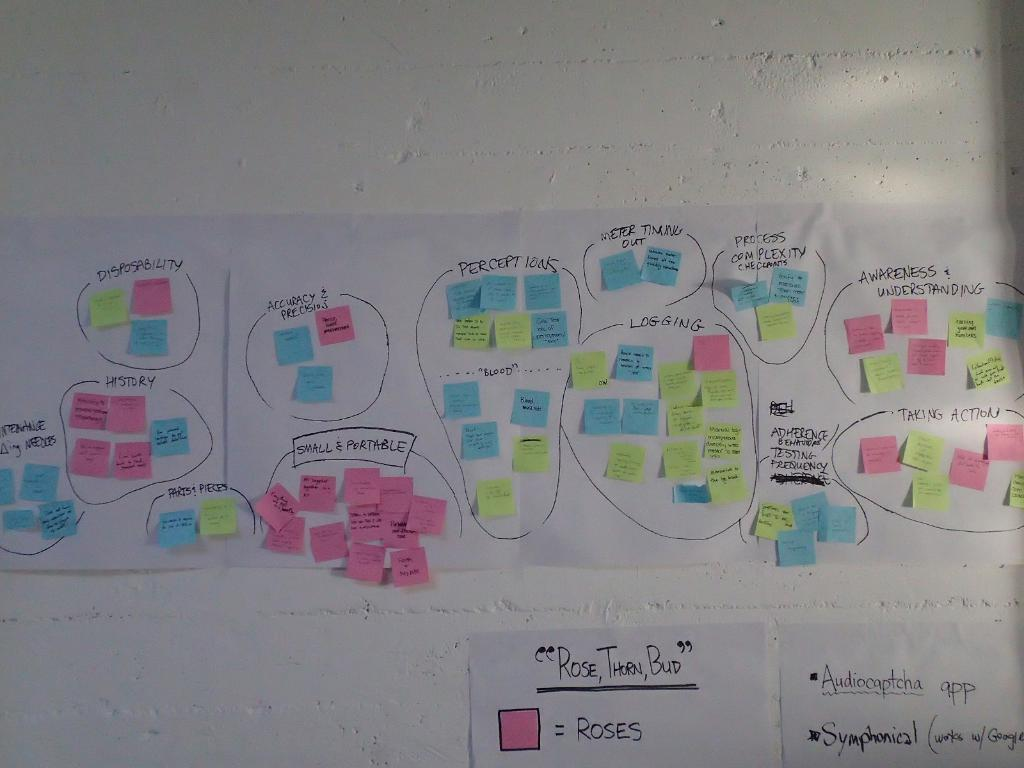What type of stationery items can be seen in the image? There are colorful sticky notes in the image. How are the sticky notes arranged in the image? The sticky notes are attached to chart papers. Where are the chart papers located in the image? The chart papers are attached to the wall. What type of trucks can be seen transporting power in the image? There are no trucks or power mentioned in the image; it only features colorful sticky notes, chart papers, and a wall. 